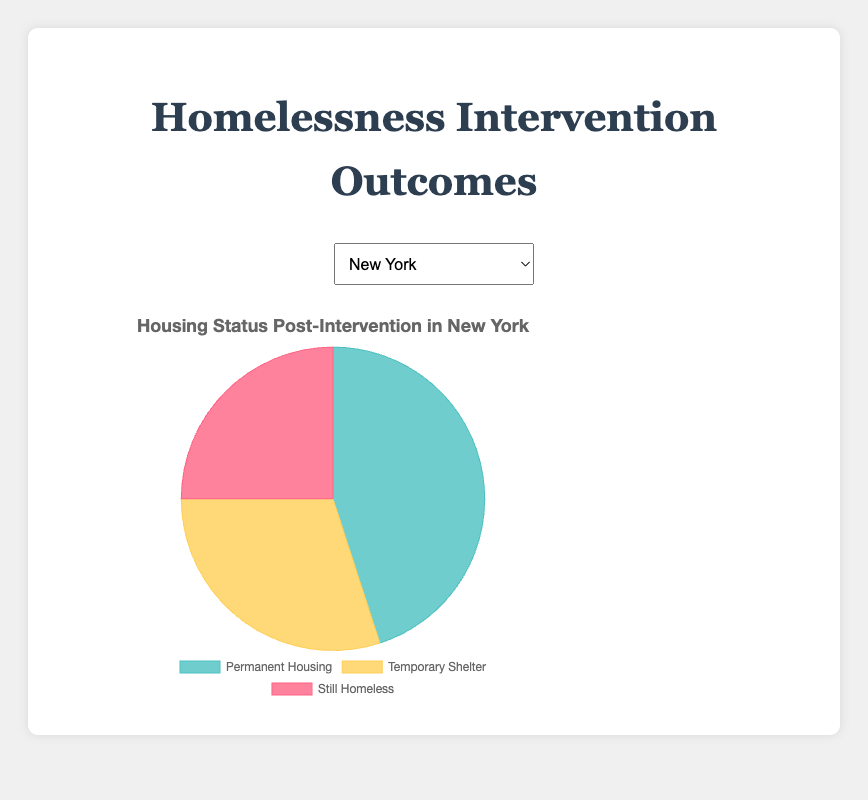What percentage of individuals in New York were placed in permanent housing post-intervention? To determine the percentage of individuals placed in permanent housing post-intervention in New York, we note that 45% were placed in permanent housing.
Answer: 45% Which city has the highest percentage of individuals still homeless post-intervention? By examining the data for the percentage of individuals still homeless, Los Angeles has the highest percentage at 30%.
Answer: Los Angeles How does the percentage of individuals in temporary shelters in Houston compare to those in San Francisco? Houston has 20% in temporary shelters, while San Francisco has 25%. Hence, San Francisco has a higher percentage of individuals in temporary shelters compared to Houston.
Answer: San Francisco What’s the difference between the percentages of individuals in permanent housing and those still homeless in Los Angeles? In Los Angeles, 50% are in permanent housing and 30% are still homeless. The difference is 50% - 30% = 20%.
Answer: 20% Which city shows the lowest percentage of individuals still homeless after the intervention? By examining each city’s data, both San Francisco and Houston have the lowest percentage of individuals still homeless at 20%.
Answer: San Francisco, Houston What is the average percentage of individuals in permanent housing across all cities? Sum up the percentages of individuals in permanent housing across the cities and divide by the number of cities. (45 + 50 + 40 + 55 + 60)/5 = 50%.
Answer: 50% By how much does the percentage of individuals in permanent housing in Chicago differ from that in New York? The percentage of individuals in permanent housing is 40% in Chicago and 45% in New York. The difference is 45% - 40% = 5%.
Answer: 5% What is the sum total percentage of individuals in temporary shelters and those still homeless in San Francisco? Sum up the percentages: 25% (temporary shelters) + 20% (still homeless) = 45%.
Answer: 45% Which colored section in the chart represents the ‘Still Homeless’ category, and what is its value for Chicago? The 'Still Homeless' category is represented by the red section. For Chicago, its value is 25%.
Answer: Red, 25% Compare the percentage of individuals placed in permanent housing in San Francisco and Houston. San Francisco has 55% in permanent housing, while Houston has 60%. Houston has a higher percentage than San Francisco.
Answer: Houston 